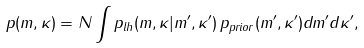Convert formula to latex. <formula><loc_0><loc_0><loc_500><loc_500>p ( m , \kappa ) = N \int p _ { l h } ( m , \kappa | m ^ { \prime } , \kappa ^ { \prime } ) \, p _ { p r i o r } ( m ^ { \prime } , \kappa ^ { \prime } ) d m ^ { \prime } d \kappa ^ { \prime } ,</formula> 